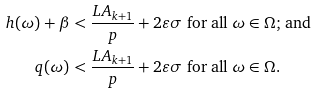<formula> <loc_0><loc_0><loc_500><loc_500>h ( \omega ) + \beta & < \frac { L A _ { k + 1 } } { p } + 2 \varepsilon \sigma \text { for all  $\omega\in\Omega$; and} \\ q ( \omega ) & < \frac { L A _ { k + 1 } } { p } + 2 \varepsilon \sigma \text { for all  $\omega\in\Omega$.}</formula> 